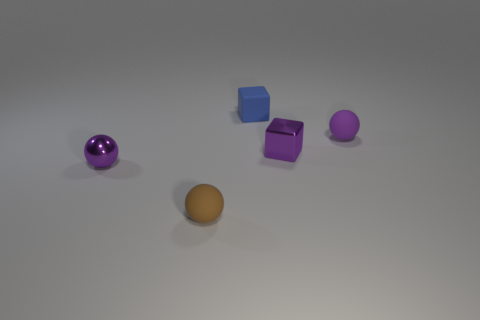How many matte things are big yellow objects or small blue objects?
Offer a very short reply. 1. Does the rubber thing that is behind the small purple rubber ball have the same shape as the purple matte object?
Offer a very short reply. No. Is the number of purple shiny balls behind the purple block greater than the number of small purple cubes?
Your response must be concise. No. What number of tiny purple things are left of the small brown rubber ball and behind the small metallic cube?
Make the answer very short. 0. There is a shiny thing that is behind the purple ball in front of the tiny purple matte thing; what color is it?
Make the answer very short. Purple. How many matte things are the same color as the metallic ball?
Your answer should be very brief. 1. Do the shiny sphere and the ball behind the shiny block have the same color?
Your answer should be very brief. Yes. Are there fewer tiny red balls than purple matte things?
Ensure brevity in your answer.  Yes. Is the number of tiny blue cubes behind the small purple matte ball greater than the number of tiny brown rubber spheres on the left side of the tiny brown thing?
Keep it short and to the point. Yes. Is the material of the blue cube the same as the small purple cube?
Keep it short and to the point. No. 